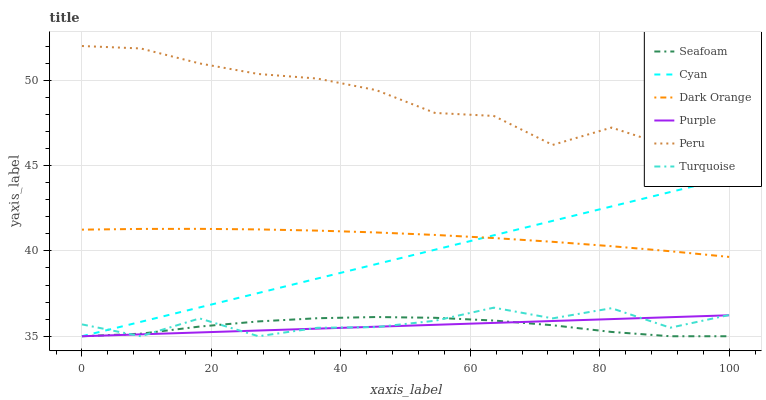Does Seafoam have the minimum area under the curve?
Answer yes or no. Yes. Does Peru have the maximum area under the curve?
Answer yes or no. Yes. Does Turquoise have the minimum area under the curve?
Answer yes or no. No. Does Turquoise have the maximum area under the curve?
Answer yes or no. No. Is Purple the smoothest?
Answer yes or no. Yes. Is Turquoise the roughest?
Answer yes or no. Yes. Is Turquoise the smoothest?
Answer yes or no. No. Is Purple the roughest?
Answer yes or no. No. Does Turquoise have the lowest value?
Answer yes or no. Yes. Does Peru have the lowest value?
Answer yes or no. No. Does Peru have the highest value?
Answer yes or no. Yes. Does Turquoise have the highest value?
Answer yes or no. No. Is Turquoise less than Dark Orange?
Answer yes or no. Yes. Is Dark Orange greater than Turquoise?
Answer yes or no. Yes. Does Cyan intersect Dark Orange?
Answer yes or no. Yes. Is Cyan less than Dark Orange?
Answer yes or no. No. Is Cyan greater than Dark Orange?
Answer yes or no. No. Does Turquoise intersect Dark Orange?
Answer yes or no. No. 